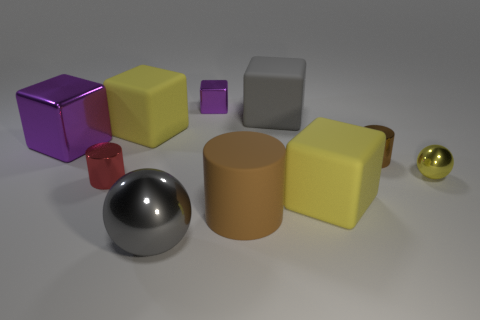Subtract all gray blocks. How many blocks are left? 4 Subtract 2 blocks. How many blocks are left? 3 Subtract all big purple cubes. How many cubes are left? 4 Subtract all blue cubes. Subtract all red spheres. How many cubes are left? 5 Subtract all cylinders. How many objects are left? 7 Subtract all large gray blocks. Subtract all yellow matte things. How many objects are left? 7 Add 5 yellow spheres. How many yellow spheres are left? 6 Add 8 brown spheres. How many brown spheres exist? 8 Subtract 0 blue cylinders. How many objects are left? 10 